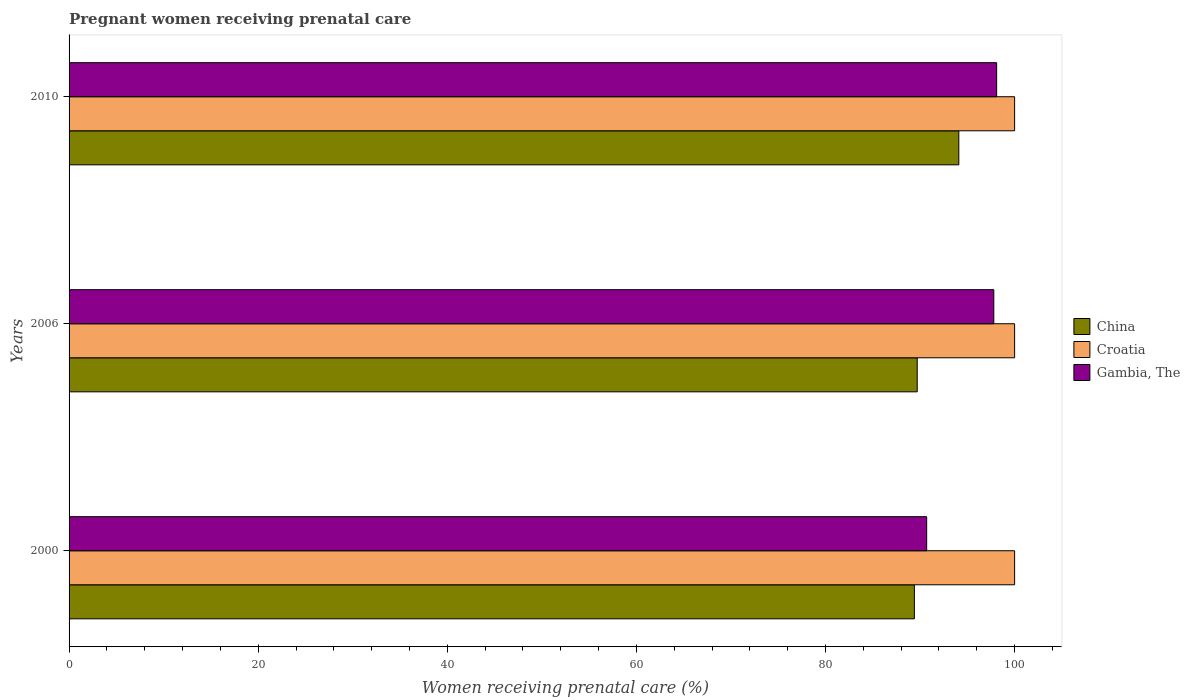How many different coloured bars are there?
Offer a terse response. 3. How many bars are there on the 1st tick from the top?
Give a very brief answer. 3. How many bars are there on the 2nd tick from the bottom?
Offer a terse response. 3. In how many cases, is the number of bars for a given year not equal to the number of legend labels?
Offer a terse response. 0. What is the percentage of women receiving prenatal care in Gambia, The in 2006?
Keep it short and to the point. 97.8. Across all years, what is the maximum percentage of women receiving prenatal care in Gambia, The?
Provide a short and direct response. 98.1. In which year was the percentage of women receiving prenatal care in China maximum?
Your answer should be compact. 2010. In which year was the percentage of women receiving prenatal care in Gambia, The minimum?
Ensure brevity in your answer.  2000. What is the total percentage of women receiving prenatal care in China in the graph?
Offer a terse response. 273.2. What is the difference between the percentage of women receiving prenatal care in China in 2000 and that in 2006?
Ensure brevity in your answer.  -0.3. What is the difference between the percentage of women receiving prenatal care in Gambia, The in 2010 and the percentage of women receiving prenatal care in Croatia in 2006?
Make the answer very short. -1.9. What is the average percentage of women receiving prenatal care in Gambia, The per year?
Make the answer very short. 95.53. In the year 2010, what is the difference between the percentage of women receiving prenatal care in Croatia and percentage of women receiving prenatal care in China?
Offer a very short reply. 5.9. What is the ratio of the percentage of women receiving prenatal care in Gambia, The in 2006 to that in 2010?
Your answer should be very brief. 1. What is the difference between the highest and the second highest percentage of women receiving prenatal care in China?
Your answer should be very brief. 4.4. What is the difference between the highest and the lowest percentage of women receiving prenatal care in China?
Give a very brief answer. 4.7. What does the 1st bar from the top in 2010 represents?
Your response must be concise. Gambia, The. What does the 2nd bar from the bottom in 2000 represents?
Keep it short and to the point. Croatia. Is it the case that in every year, the sum of the percentage of women receiving prenatal care in Gambia, The and percentage of women receiving prenatal care in Croatia is greater than the percentage of women receiving prenatal care in China?
Ensure brevity in your answer.  Yes. How many years are there in the graph?
Your response must be concise. 3. What is the difference between two consecutive major ticks on the X-axis?
Provide a short and direct response. 20. Are the values on the major ticks of X-axis written in scientific E-notation?
Give a very brief answer. No. Does the graph contain any zero values?
Keep it short and to the point. No. Does the graph contain grids?
Provide a short and direct response. No. Where does the legend appear in the graph?
Offer a very short reply. Center right. What is the title of the graph?
Your answer should be compact. Pregnant women receiving prenatal care. What is the label or title of the X-axis?
Your answer should be very brief. Women receiving prenatal care (%). What is the Women receiving prenatal care (%) in China in 2000?
Provide a succinct answer. 89.4. What is the Women receiving prenatal care (%) in Croatia in 2000?
Keep it short and to the point. 100. What is the Women receiving prenatal care (%) of Gambia, The in 2000?
Your answer should be compact. 90.7. What is the Women receiving prenatal care (%) of China in 2006?
Your response must be concise. 89.7. What is the Women receiving prenatal care (%) in Gambia, The in 2006?
Offer a very short reply. 97.8. What is the Women receiving prenatal care (%) in China in 2010?
Give a very brief answer. 94.1. What is the Women receiving prenatal care (%) in Croatia in 2010?
Keep it short and to the point. 100. What is the Women receiving prenatal care (%) of Gambia, The in 2010?
Provide a short and direct response. 98.1. Across all years, what is the maximum Women receiving prenatal care (%) of China?
Give a very brief answer. 94.1. Across all years, what is the maximum Women receiving prenatal care (%) in Gambia, The?
Keep it short and to the point. 98.1. Across all years, what is the minimum Women receiving prenatal care (%) of China?
Your answer should be very brief. 89.4. Across all years, what is the minimum Women receiving prenatal care (%) of Croatia?
Provide a short and direct response. 100. Across all years, what is the minimum Women receiving prenatal care (%) in Gambia, The?
Give a very brief answer. 90.7. What is the total Women receiving prenatal care (%) in China in the graph?
Provide a short and direct response. 273.2. What is the total Women receiving prenatal care (%) of Croatia in the graph?
Offer a terse response. 300. What is the total Women receiving prenatal care (%) in Gambia, The in the graph?
Your answer should be compact. 286.6. What is the difference between the Women receiving prenatal care (%) in Croatia in 2000 and that in 2006?
Ensure brevity in your answer.  0. What is the difference between the Women receiving prenatal care (%) of China in 2000 and that in 2010?
Provide a short and direct response. -4.7. What is the difference between the Women receiving prenatal care (%) in Croatia in 2000 and that in 2010?
Give a very brief answer. 0. What is the difference between the Women receiving prenatal care (%) of Croatia in 2006 and that in 2010?
Your response must be concise. 0. What is the difference between the Women receiving prenatal care (%) of Gambia, The in 2006 and that in 2010?
Provide a succinct answer. -0.3. What is the difference between the Women receiving prenatal care (%) in China in 2000 and the Women receiving prenatal care (%) in Croatia in 2010?
Give a very brief answer. -10.6. What is the difference between the Women receiving prenatal care (%) in China in 2006 and the Women receiving prenatal care (%) in Croatia in 2010?
Ensure brevity in your answer.  -10.3. What is the difference between the Women receiving prenatal care (%) in Croatia in 2006 and the Women receiving prenatal care (%) in Gambia, The in 2010?
Offer a very short reply. 1.9. What is the average Women receiving prenatal care (%) of China per year?
Make the answer very short. 91.07. What is the average Women receiving prenatal care (%) in Gambia, The per year?
Ensure brevity in your answer.  95.53. In the year 2000, what is the difference between the Women receiving prenatal care (%) of China and Women receiving prenatal care (%) of Gambia, The?
Your answer should be compact. -1.3. In the year 2006, what is the difference between the Women receiving prenatal care (%) in China and Women receiving prenatal care (%) in Croatia?
Your answer should be compact. -10.3. In the year 2010, what is the difference between the Women receiving prenatal care (%) of China and Women receiving prenatal care (%) of Gambia, The?
Make the answer very short. -4. In the year 2010, what is the difference between the Women receiving prenatal care (%) of Croatia and Women receiving prenatal care (%) of Gambia, The?
Provide a succinct answer. 1.9. What is the ratio of the Women receiving prenatal care (%) in China in 2000 to that in 2006?
Make the answer very short. 1. What is the ratio of the Women receiving prenatal care (%) of Croatia in 2000 to that in 2006?
Your answer should be very brief. 1. What is the ratio of the Women receiving prenatal care (%) of Gambia, The in 2000 to that in 2006?
Ensure brevity in your answer.  0.93. What is the ratio of the Women receiving prenatal care (%) in China in 2000 to that in 2010?
Your answer should be compact. 0.95. What is the ratio of the Women receiving prenatal care (%) of Croatia in 2000 to that in 2010?
Your answer should be compact. 1. What is the ratio of the Women receiving prenatal care (%) of Gambia, The in 2000 to that in 2010?
Provide a succinct answer. 0.92. What is the ratio of the Women receiving prenatal care (%) of China in 2006 to that in 2010?
Your answer should be very brief. 0.95. What is the ratio of the Women receiving prenatal care (%) of Croatia in 2006 to that in 2010?
Offer a very short reply. 1. What is the difference between the highest and the second highest Women receiving prenatal care (%) in Croatia?
Your answer should be very brief. 0. What is the difference between the highest and the second highest Women receiving prenatal care (%) in Gambia, The?
Your response must be concise. 0.3. 